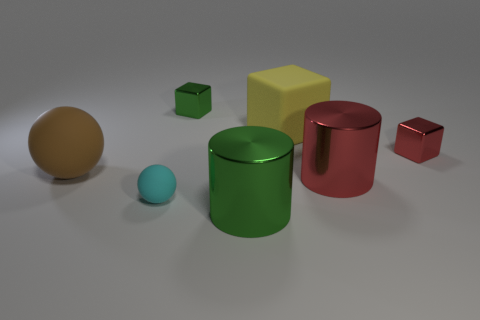Is there a large thing that is behind the green metallic object in front of the big cylinder that is behind the tiny cyan object?
Your answer should be compact. Yes. There is a green metal object in front of the big brown matte object; what size is it?
Ensure brevity in your answer.  Large. There is a red thing that is the same size as the brown matte ball; what is it made of?
Your answer should be compact. Metal. Is the shape of the cyan thing the same as the big brown matte thing?
Your response must be concise. Yes. What number of objects are either brown balls or tiny things behind the brown rubber ball?
Keep it short and to the point. 3. Is the size of the green metallic thing in front of the cyan rubber sphere the same as the cyan sphere?
Your answer should be very brief. No. There is a green metallic thing that is in front of the tiny shiny block right of the big red metal object; how many brown rubber objects are to the right of it?
Ensure brevity in your answer.  0. How many red things are either cylinders or big matte cylinders?
Your response must be concise. 1. What color is the small thing that is made of the same material as the large yellow object?
Offer a terse response. Cyan. What number of big things are yellow matte blocks or red matte cubes?
Your answer should be very brief. 1. 